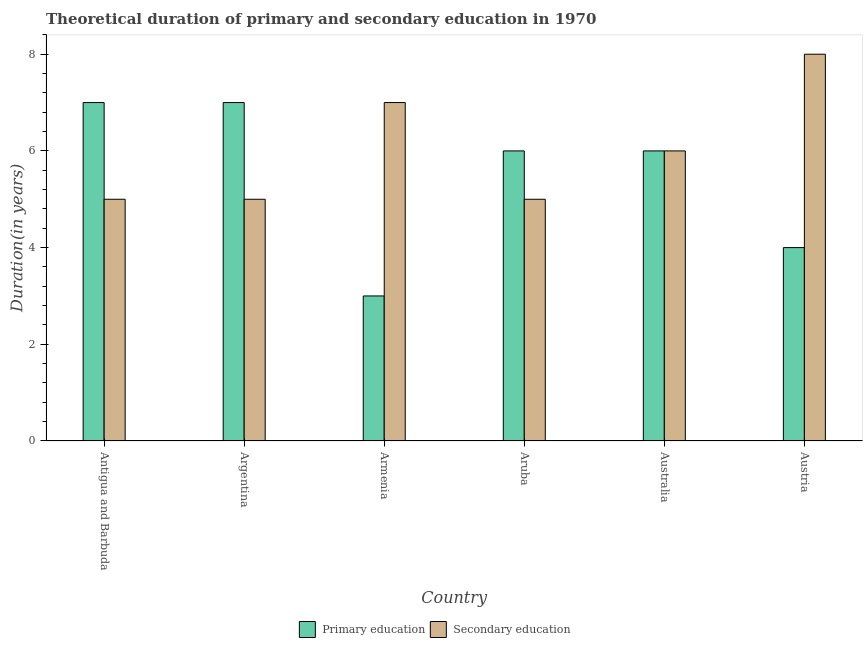How many bars are there on the 3rd tick from the right?
Provide a succinct answer. 2. What is the label of the 6th group of bars from the left?
Offer a very short reply. Austria. What is the duration of secondary education in Armenia?
Your answer should be compact. 7. Across all countries, what is the maximum duration of secondary education?
Your answer should be very brief. 8. Across all countries, what is the minimum duration of secondary education?
Provide a short and direct response. 5. In which country was the duration of primary education maximum?
Your response must be concise. Antigua and Barbuda. In which country was the duration of primary education minimum?
Offer a very short reply. Armenia. What is the total duration of primary education in the graph?
Give a very brief answer. 33. What is the difference between the duration of secondary education in Argentina and that in Austria?
Ensure brevity in your answer.  -3. What is the difference between the duration of primary education in Australia and the duration of secondary education in Austria?
Your response must be concise. -2. What is the difference between the duration of secondary education and duration of primary education in Armenia?
Ensure brevity in your answer.  4. In how many countries, is the duration of primary education greater than 3.6 years?
Give a very brief answer. 5. What is the ratio of the duration of secondary education in Aruba to that in Austria?
Keep it short and to the point. 0.62. What is the difference between the highest and the second highest duration of primary education?
Provide a short and direct response. 0. What is the difference between the highest and the lowest duration of primary education?
Keep it short and to the point. 4. What does the 1st bar from the left in Australia represents?
Offer a terse response. Primary education. What does the 1st bar from the right in Argentina represents?
Make the answer very short. Secondary education. How many bars are there?
Provide a short and direct response. 12. How many countries are there in the graph?
Give a very brief answer. 6. What is the title of the graph?
Your answer should be very brief. Theoretical duration of primary and secondary education in 1970. What is the label or title of the X-axis?
Provide a short and direct response. Country. What is the label or title of the Y-axis?
Provide a succinct answer. Duration(in years). What is the Duration(in years) in Primary education in Argentina?
Your answer should be very brief. 7. What is the Duration(in years) in Secondary education in Armenia?
Keep it short and to the point. 7. What is the Duration(in years) in Primary education in Australia?
Provide a short and direct response. 6. What is the Duration(in years) in Primary education in Austria?
Your response must be concise. 4. Across all countries, what is the maximum Duration(in years) of Secondary education?
Your answer should be compact. 8. What is the difference between the Duration(in years) in Secondary education in Antigua and Barbuda and that in Armenia?
Provide a short and direct response. -2. What is the difference between the Duration(in years) of Primary education in Antigua and Barbuda and that in Aruba?
Offer a very short reply. 1. What is the difference between the Duration(in years) in Secondary education in Antigua and Barbuda and that in Aruba?
Offer a very short reply. 0. What is the difference between the Duration(in years) of Secondary education in Antigua and Barbuda and that in Australia?
Your answer should be compact. -1. What is the difference between the Duration(in years) of Primary education in Argentina and that in Armenia?
Ensure brevity in your answer.  4. What is the difference between the Duration(in years) of Secondary education in Argentina and that in Aruba?
Offer a very short reply. 0. What is the difference between the Duration(in years) of Secondary education in Argentina and that in Australia?
Your answer should be compact. -1. What is the difference between the Duration(in years) of Secondary education in Argentina and that in Austria?
Provide a short and direct response. -3. What is the difference between the Duration(in years) in Primary education in Armenia and that in Aruba?
Offer a very short reply. -3. What is the difference between the Duration(in years) of Secondary education in Armenia and that in Aruba?
Your response must be concise. 2. What is the difference between the Duration(in years) in Secondary education in Armenia and that in Australia?
Provide a short and direct response. 1. What is the difference between the Duration(in years) in Secondary education in Armenia and that in Austria?
Offer a very short reply. -1. What is the difference between the Duration(in years) in Primary education in Aruba and that in Australia?
Make the answer very short. 0. What is the difference between the Duration(in years) of Secondary education in Aruba and that in Australia?
Make the answer very short. -1. What is the difference between the Duration(in years) of Primary education in Australia and that in Austria?
Provide a succinct answer. 2. What is the difference between the Duration(in years) in Primary education in Antigua and Barbuda and the Duration(in years) in Secondary education in Argentina?
Provide a short and direct response. 2. What is the difference between the Duration(in years) in Primary education in Antigua and Barbuda and the Duration(in years) in Secondary education in Aruba?
Your response must be concise. 2. What is the difference between the Duration(in years) in Primary education in Antigua and Barbuda and the Duration(in years) in Secondary education in Australia?
Offer a very short reply. 1. What is the difference between the Duration(in years) of Primary education in Antigua and Barbuda and the Duration(in years) of Secondary education in Austria?
Ensure brevity in your answer.  -1. What is the difference between the Duration(in years) of Primary education in Argentina and the Duration(in years) of Secondary education in Armenia?
Make the answer very short. 0. What is the difference between the Duration(in years) in Primary education in Argentina and the Duration(in years) in Secondary education in Aruba?
Your answer should be very brief. 2. What is the difference between the Duration(in years) in Primary education in Armenia and the Duration(in years) in Secondary education in Aruba?
Offer a terse response. -2. What is the difference between the Duration(in years) in Primary education in Armenia and the Duration(in years) in Secondary education in Australia?
Make the answer very short. -3. What is the average Duration(in years) of Primary education per country?
Your answer should be very brief. 5.5. What is the difference between the Duration(in years) of Primary education and Duration(in years) of Secondary education in Argentina?
Make the answer very short. 2. What is the difference between the Duration(in years) in Primary education and Duration(in years) in Secondary education in Armenia?
Provide a short and direct response. -4. What is the ratio of the Duration(in years) in Secondary education in Antigua and Barbuda to that in Argentina?
Your answer should be compact. 1. What is the ratio of the Duration(in years) in Primary education in Antigua and Barbuda to that in Armenia?
Give a very brief answer. 2.33. What is the ratio of the Duration(in years) in Secondary education in Antigua and Barbuda to that in Armenia?
Offer a very short reply. 0.71. What is the ratio of the Duration(in years) of Primary education in Antigua and Barbuda to that in Aruba?
Offer a terse response. 1.17. What is the ratio of the Duration(in years) of Primary education in Antigua and Barbuda to that in Austria?
Keep it short and to the point. 1.75. What is the ratio of the Duration(in years) of Primary education in Argentina to that in Armenia?
Ensure brevity in your answer.  2.33. What is the ratio of the Duration(in years) of Secondary education in Argentina to that in Armenia?
Ensure brevity in your answer.  0.71. What is the ratio of the Duration(in years) of Secondary education in Argentina to that in Australia?
Your response must be concise. 0.83. What is the ratio of the Duration(in years) of Secondary education in Argentina to that in Austria?
Your answer should be very brief. 0.62. What is the ratio of the Duration(in years) in Primary education in Armenia to that in Aruba?
Provide a succinct answer. 0.5. What is the ratio of the Duration(in years) in Primary education in Armenia to that in Australia?
Your answer should be compact. 0.5. What is the ratio of the Duration(in years) in Secondary education in Aruba to that in Australia?
Provide a short and direct response. 0.83. What is the ratio of the Duration(in years) of Secondary education in Aruba to that in Austria?
Provide a succinct answer. 0.62. What is the ratio of the Duration(in years) in Primary education in Australia to that in Austria?
Ensure brevity in your answer.  1.5. What is the ratio of the Duration(in years) of Secondary education in Australia to that in Austria?
Offer a very short reply. 0.75. What is the difference between the highest and the second highest Duration(in years) in Primary education?
Offer a terse response. 0. What is the difference between the highest and the second highest Duration(in years) in Secondary education?
Your answer should be very brief. 1. 